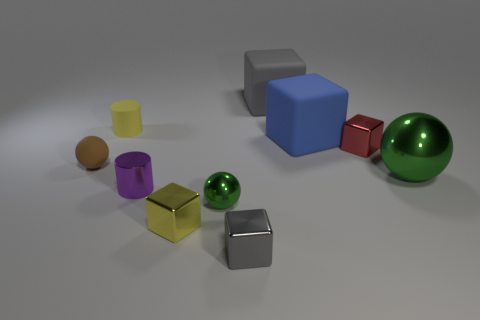Subtract all tiny red cubes. How many cubes are left? 4 Subtract all brown balls. How many balls are left? 2 Subtract 1 spheres. How many spheres are left? 2 Add 8 small green metallic things. How many small green metallic things are left? 9 Add 3 red metallic cubes. How many red metallic cubes exist? 4 Subtract 0 purple cubes. How many objects are left? 10 Subtract all balls. How many objects are left? 7 Subtract all red cylinders. Subtract all blue spheres. How many cylinders are left? 2 Subtract all yellow blocks. How many gray cylinders are left? 0 Subtract all blue objects. Subtract all rubber balls. How many objects are left? 8 